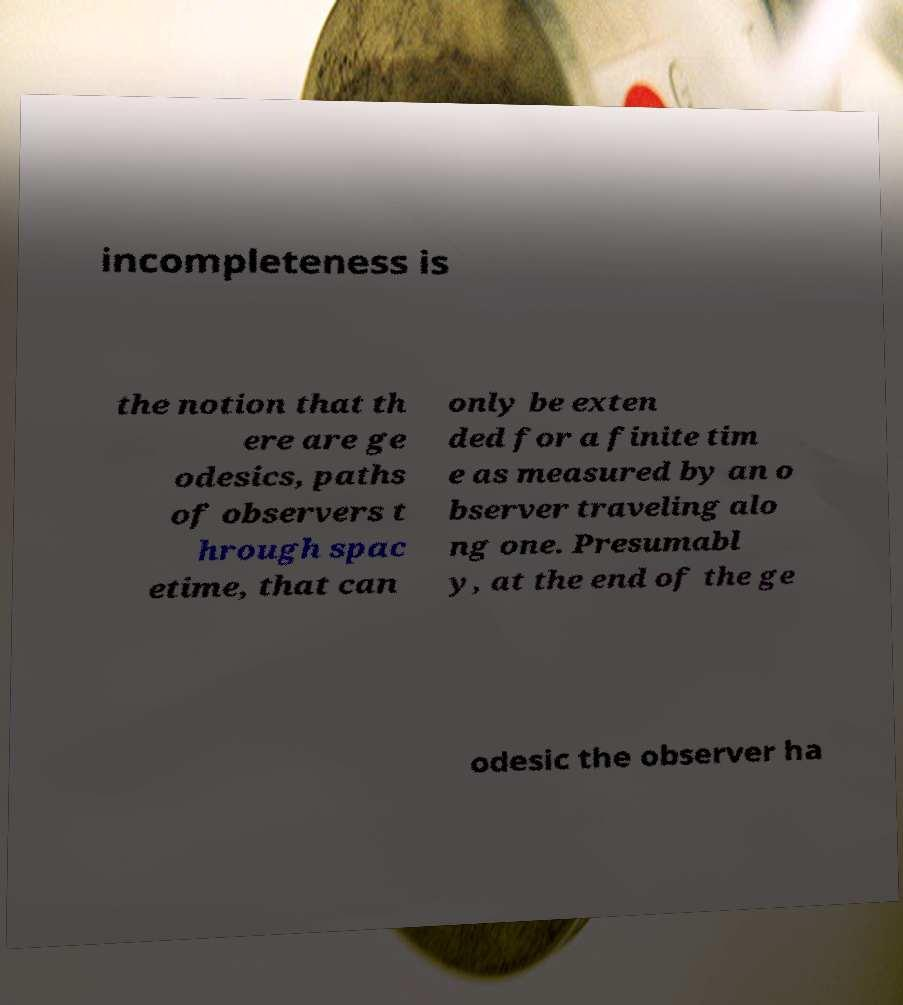There's text embedded in this image that I need extracted. Can you transcribe it verbatim? incompleteness is the notion that th ere are ge odesics, paths of observers t hrough spac etime, that can only be exten ded for a finite tim e as measured by an o bserver traveling alo ng one. Presumabl y, at the end of the ge odesic the observer ha 